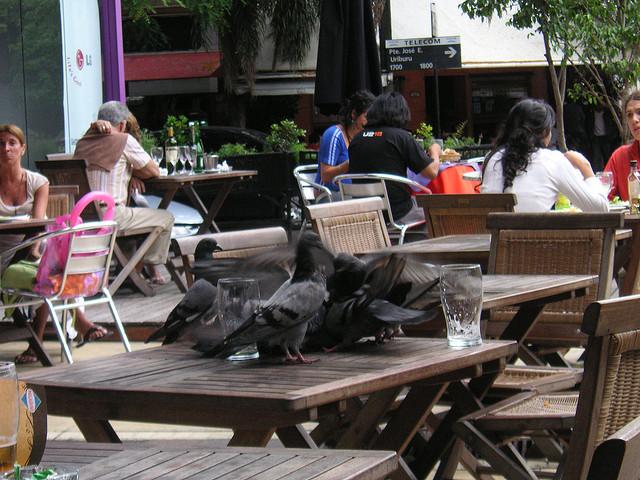Is anyone in the scene wearing blue?
Give a very brief answer. Yes. What color are the birds on the table?
Answer briefly. Gray. How many glasses are on the table?
Give a very brief answer. 2. 